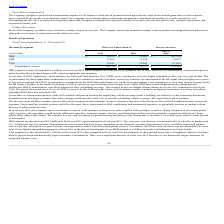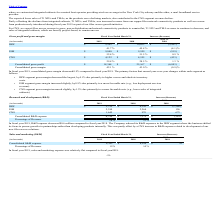According to Westell Technologies's financial document, Why did IBW segment revenue decrease in 2019 compared to 2018? lower sales of DAS conditioners, commercial repeaters, and related ancillary products (passive RF system components and antennas). The document states: "hen compared to fiscal year 2018, primarily due to lower sales of DAS conditioners, commercial repeaters, and related ancillary products (passive RF s..." Also, What is largely a function of the decline in sales of DAS conditioners and commercial repeaters? The decrease from ancillary products (passive RF system components and antennas) revenue. The document states: "The decrease from ancillary products (passive RF system components and antennas) revenue is largely a function of the decline in sales of DAS conditio..." Also, What did deployment services revenue largely depend on? one domestic customer that continues to buy our ISM remotes and support services but that, subsequent to a price increase, no longer places orders with us for deployment services. The document states: "nt services revenue had been largely dependent on one domestic customer that continues to buy our ISM remotes and support services but that, subsequen..." Also, can you calculate: What is the proportion of revenue from the IBW and ISM segment over total revenue in 2018? To answer this question, I need to perform calculations using the financial data. The calculation is: (23,265+19,350)/58,577 , which equals 0.73. This is based on the information: "ISM 17,263 19,350 (2,087 ) Consolidated revenue $ 43,570 $ 58,577 $ (15,007) IBW $ 12,474 $ 23,265 $ (10,791)..." The key data points involved are: 19,350, 23,265, 58,577. Also, can you calculate: What is the percentage change in revenue from the CNS segment in 2019 compared to 2018? To answer this question, I need to perform calculations using the financial data. The calculation is: -2,129/15,962 , which equals -13.34 (percentage). This is based on the information: "CNS 13,833 15,962 (2,129 ) CNS 13,833 15,962 (2,129 )..." The key data points involved are: 15,962, 2,129. Also, can you calculate: What is the average revenue from all three segments in 2019? To answer this question, I need to perform calculations using the financial data. The calculation is: (12,474+17,263+13,833)/3 , which equals 14523.33 (in thousands). This is based on the information: "CNS 13,833 15,962 (2,129 ) ISM 17,263 19,350 (2,087 ) IBW $ 12,474 $ 23,265 $ (10,791)..." The key data points involved are: 12,474, 13,833, 17,263. 